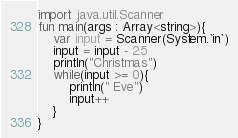Convert code to text. <code><loc_0><loc_0><loc_500><loc_500><_Kotlin_>import java.util.Scanner
fun main(args : Array<string>){
    var input = Scanner(System.`in`)
    input = input - 25
    println("Christmas")
    while(input >= 0){
        println(" Eve")
        input++
    }
}
</code> 